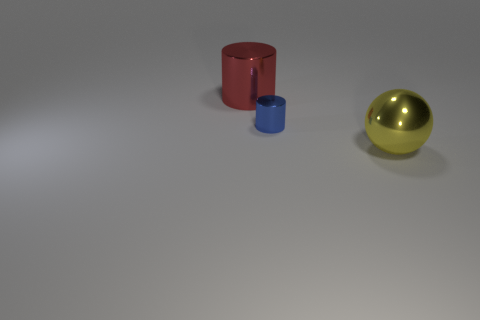There is a ball that is the same material as the tiny cylinder; what color is it?
Provide a short and direct response. Yellow. There is a metallic thing to the left of the shiny cylinder that is to the right of the large red thing; is there a big metallic sphere in front of it?
Provide a short and direct response. Yes. The tiny blue object has what shape?
Make the answer very short. Cylinder. Is the number of yellow metallic things that are behind the large red metallic thing less than the number of purple spheres?
Provide a succinct answer. No. Is there another big yellow object that has the same shape as the big yellow thing?
Provide a succinct answer. No. What is the shape of the red shiny object that is the same size as the yellow shiny object?
Your answer should be very brief. Cylinder. What number of objects are either red objects or purple shiny cylinders?
Give a very brief answer. 1. Is there a big brown ball?
Keep it short and to the point. No. Is the number of blue cylinders less than the number of large red shiny spheres?
Your answer should be compact. No. Is there a cyan rubber cube of the same size as the blue object?
Your answer should be compact. No. 